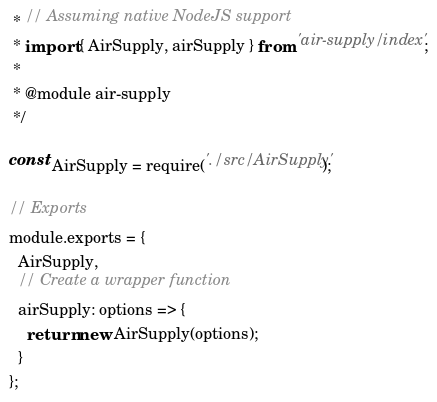<code> <loc_0><loc_0><loc_500><loc_500><_JavaScript_> * // Assuming native NodeJS support
 * import { AirSupply, airSupply } from 'air-supply/index';
 *
 * @module air-supply
 */

const AirSupply = require('./src/AirSupply');

// Exports
module.exports = {
  AirSupply,
  // Create a wrapper function
  airSupply: options => {
    return new AirSupply(options);
  }
};
</code> 